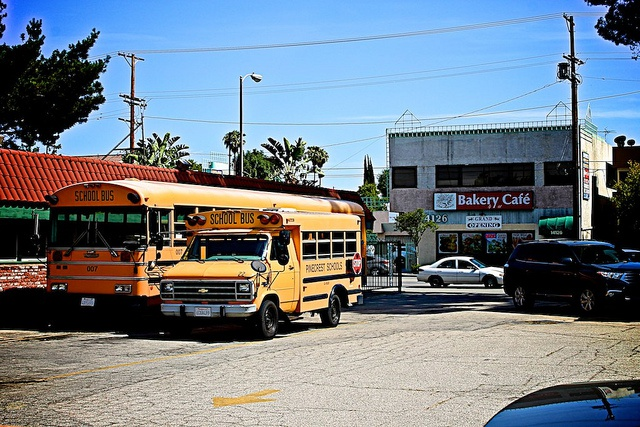Describe the objects in this image and their specific colors. I can see bus in navy, black, gold, khaki, and gray tones, bus in navy, black, maroon, and ivory tones, truck in navy, black, gray, and blue tones, car in navy, black, gray, and blue tones, and car in navy, black, blue, and gray tones in this image. 